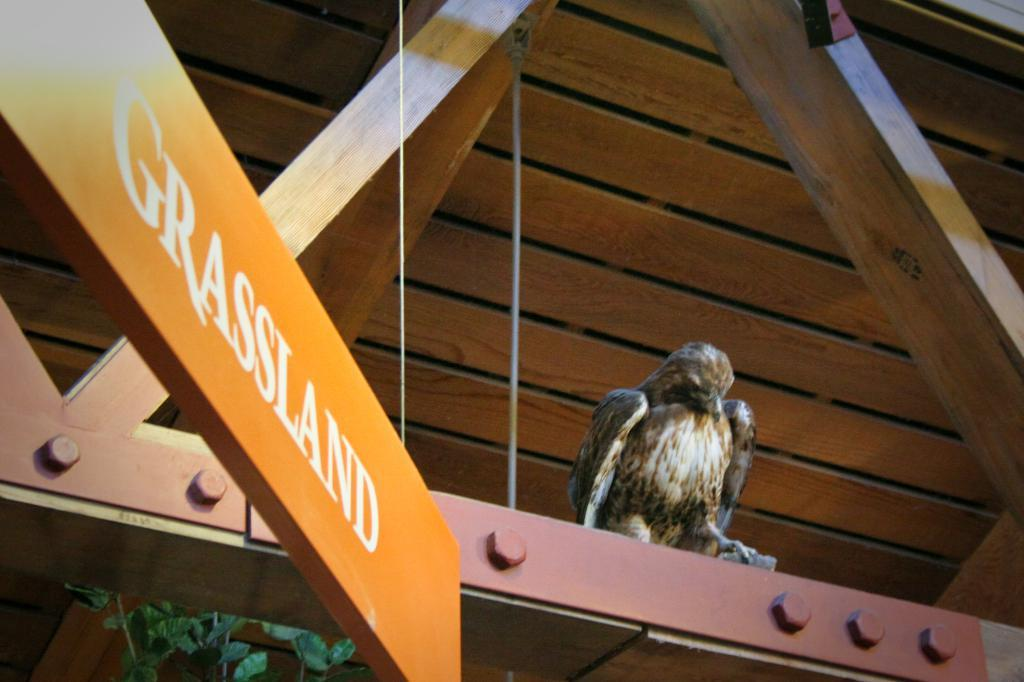What is the main subject in the center of the image? There is a bird in the center of the image. What structure can be seen at the top of the image? There is a roof visible at the top of the image. What object is located on the left side of the image? There is a board on the left side of the image. What type of vegetation is present in the image? Leaves are present in the image. How many tigers are visible in the image? There are no tigers present in the image. What type of rice is being cooked in the image? There is no rice visible in the image. 